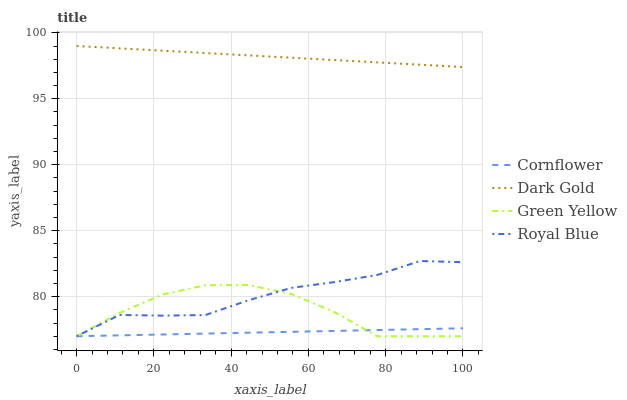Does Cornflower have the minimum area under the curve?
Answer yes or no. Yes. Does Dark Gold have the maximum area under the curve?
Answer yes or no. Yes. Does Green Yellow have the minimum area under the curve?
Answer yes or no. No. Does Green Yellow have the maximum area under the curve?
Answer yes or no. No. Is Cornflower the smoothest?
Answer yes or no. Yes. Is Green Yellow the roughest?
Answer yes or no. Yes. Is Royal Blue the smoothest?
Answer yes or no. No. Is Royal Blue the roughest?
Answer yes or no. No. Does Dark Gold have the lowest value?
Answer yes or no. No. Does Green Yellow have the highest value?
Answer yes or no. No. Is Royal Blue less than Dark Gold?
Answer yes or no. Yes. Is Dark Gold greater than Green Yellow?
Answer yes or no. Yes. Does Royal Blue intersect Dark Gold?
Answer yes or no. No. 